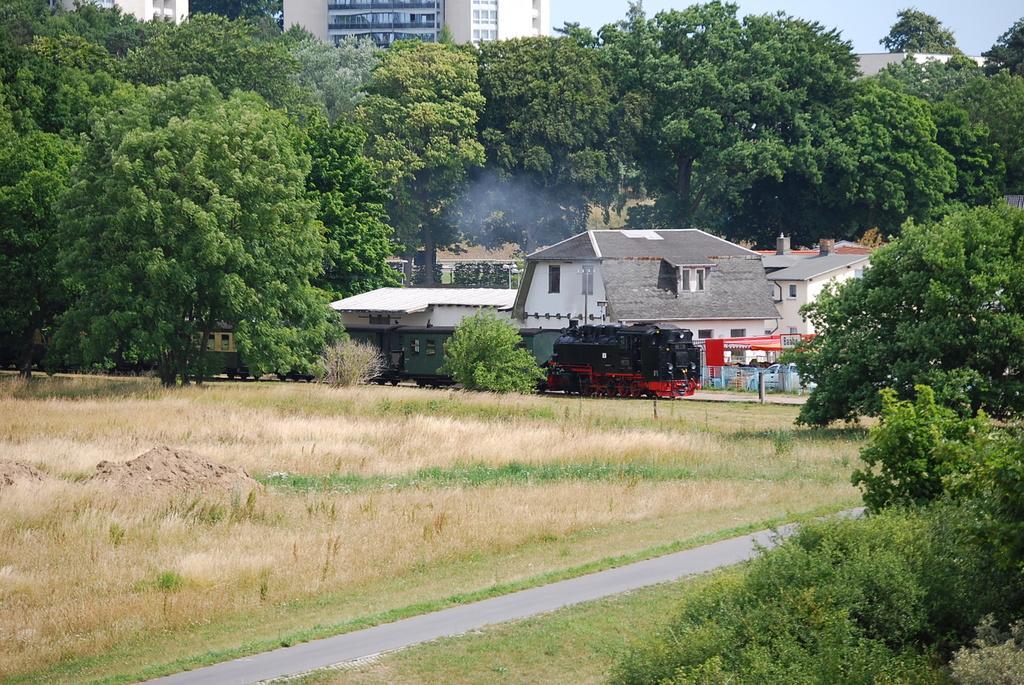Could you give a brief overview of what you see in this image? In this picture I can see few houses and buildings, trees and a vehicle and I can see smoke from the house and few cars and I can see grass on the ground and few plants and a cloudy sky. 